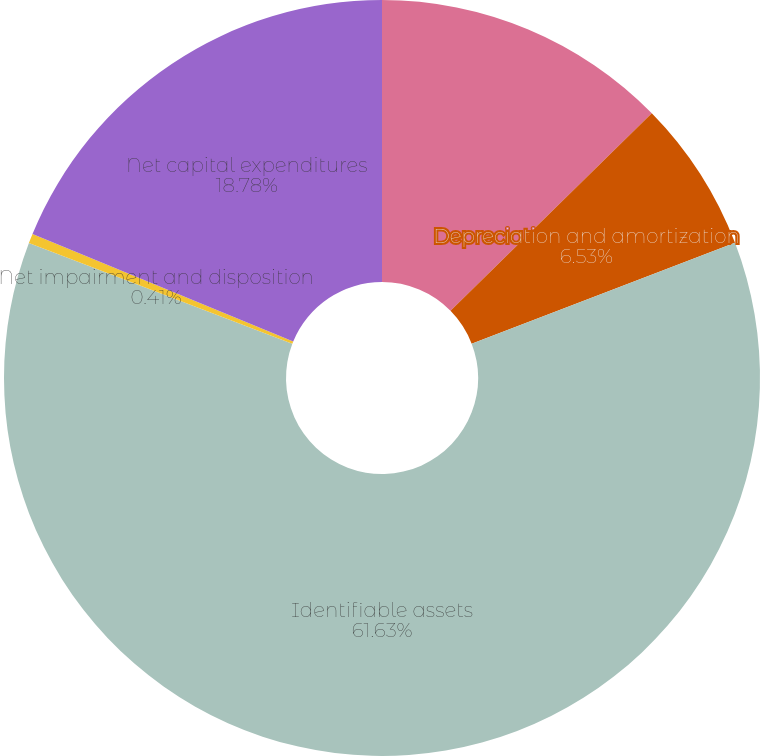Convert chart to OTSL. <chart><loc_0><loc_0><loc_500><loc_500><pie_chart><fcel>Earnings/(loss) before income<fcel>Depreciation and amortization<fcel>Identifiable assets<fcel>Net impairment and disposition<fcel>Net capital expenditures<nl><fcel>12.65%<fcel>6.53%<fcel>61.63%<fcel>0.41%<fcel>18.78%<nl></chart> 